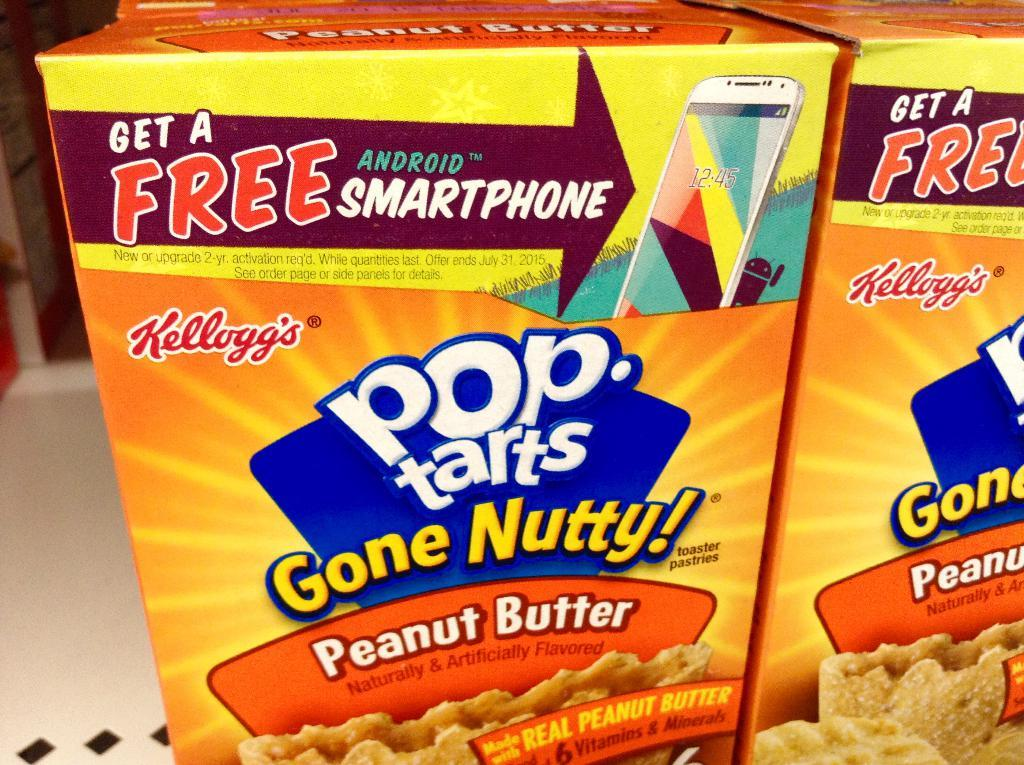Provide a one-sentence caption for the provided image. The box of Pop Tarts advertises a free android smartphone. 